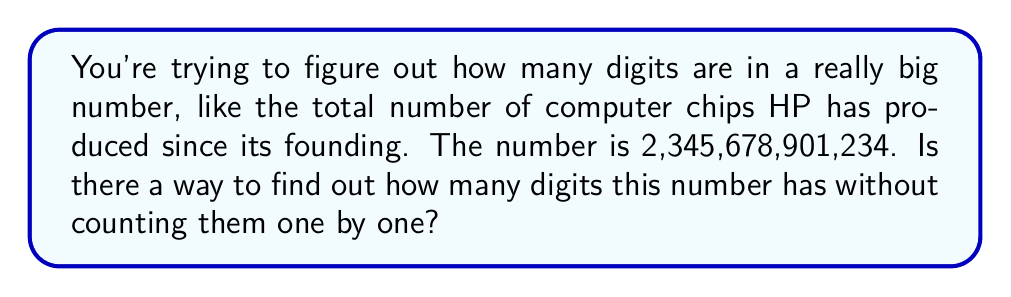Show me your answer to this math problem. Sure! Let's break this down into simpler steps:

1. In math, we can use something called logarithms to find the number of digits in a big number. Don't worry about the fancy term; it's just a tool that helps us.

2. The key is to use the base-10 logarithm, which we write as $\log_{10}$ or sometimes just $\log$.

3. The formula we use is:
   Number of digits = $\lfloor \log_{10}(n) \rfloor + 1$
   Where $n$ is our big number, and $\lfloor \rfloor$ means we round down to the nearest whole number.

4. Let's plug in our number:
   $\log_{10}(2,345,678,901,234) \approx 12.37$

5. We round 12.37 down to 12.

6. Then we add 1:
   $12 + 1 = 13$

So, without counting, we've found that the number has 13 digits!

This method works because $\log_{10}$ essentially tells us how many times we need to multiply 10 by itself to get our number. Each time we multiply by 10, we add a digit.
Answer: 13 digits 